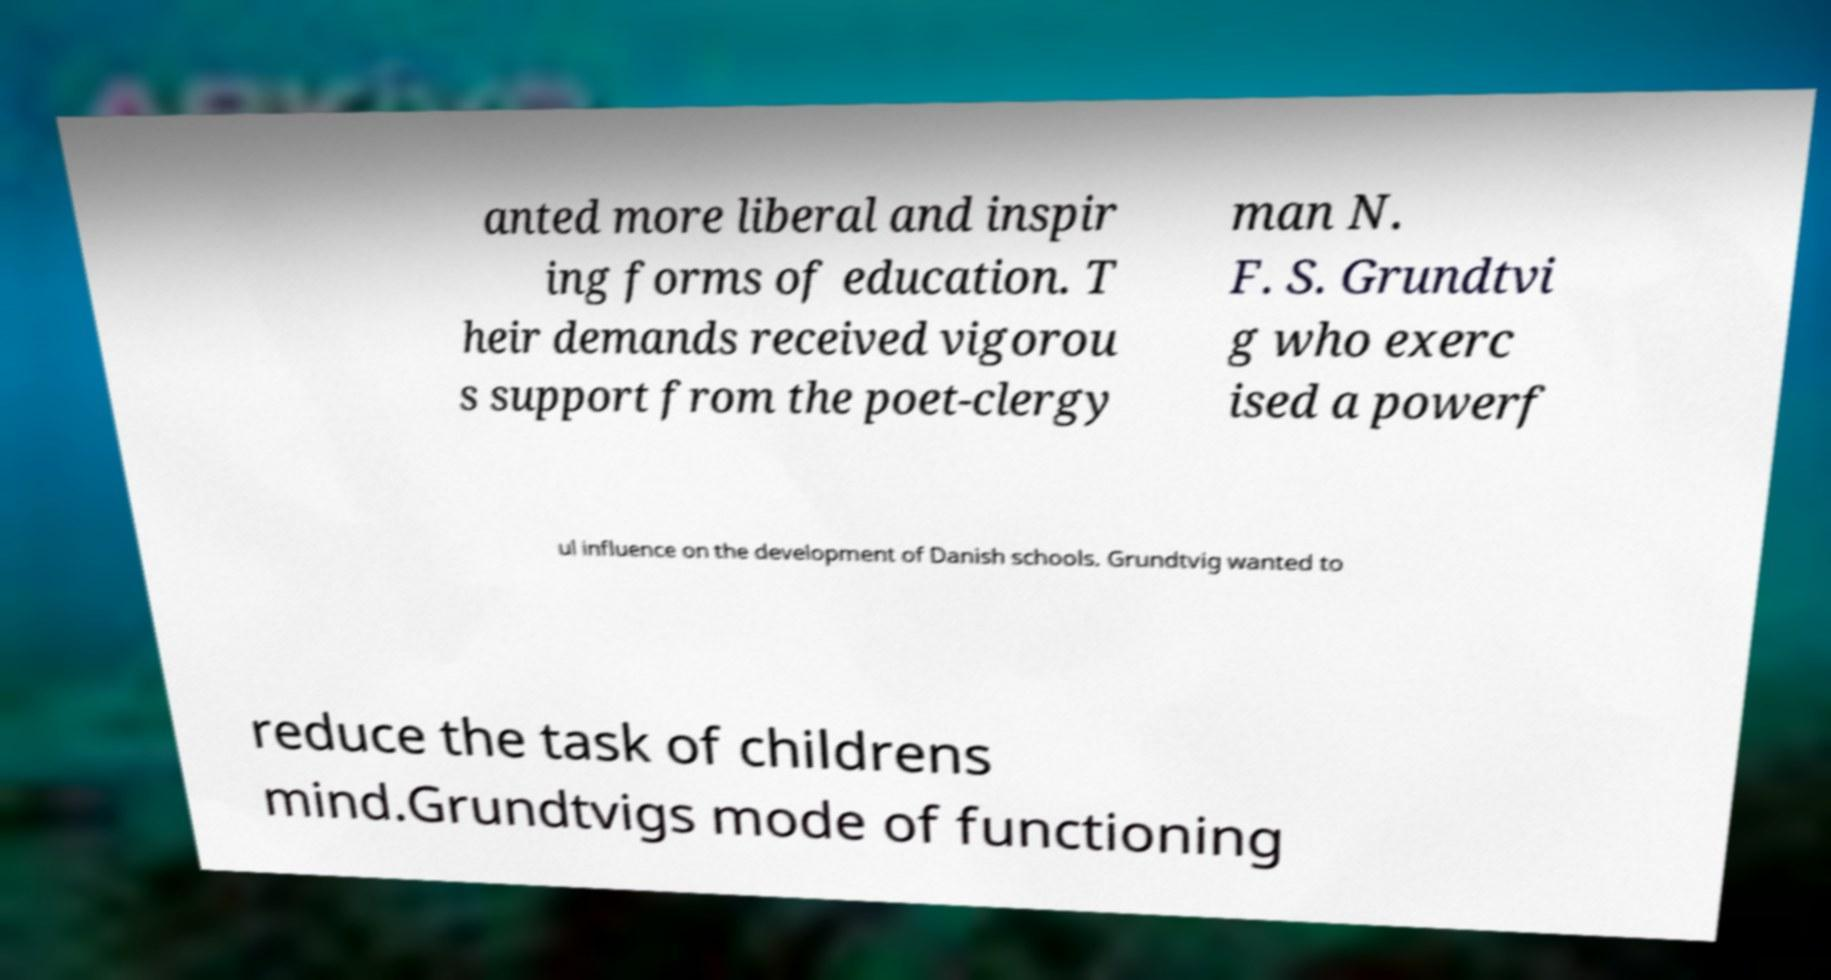I need the written content from this picture converted into text. Can you do that? anted more liberal and inspir ing forms of education. T heir demands received vigorou s support from the poet-clergy man N. F. S. Grundtvi g who exerc ised a powerf ul influence on the development of Danish schools. Grundtvig wanted to reduce the task of childrens mind.Grundtvigs mode of functioning 